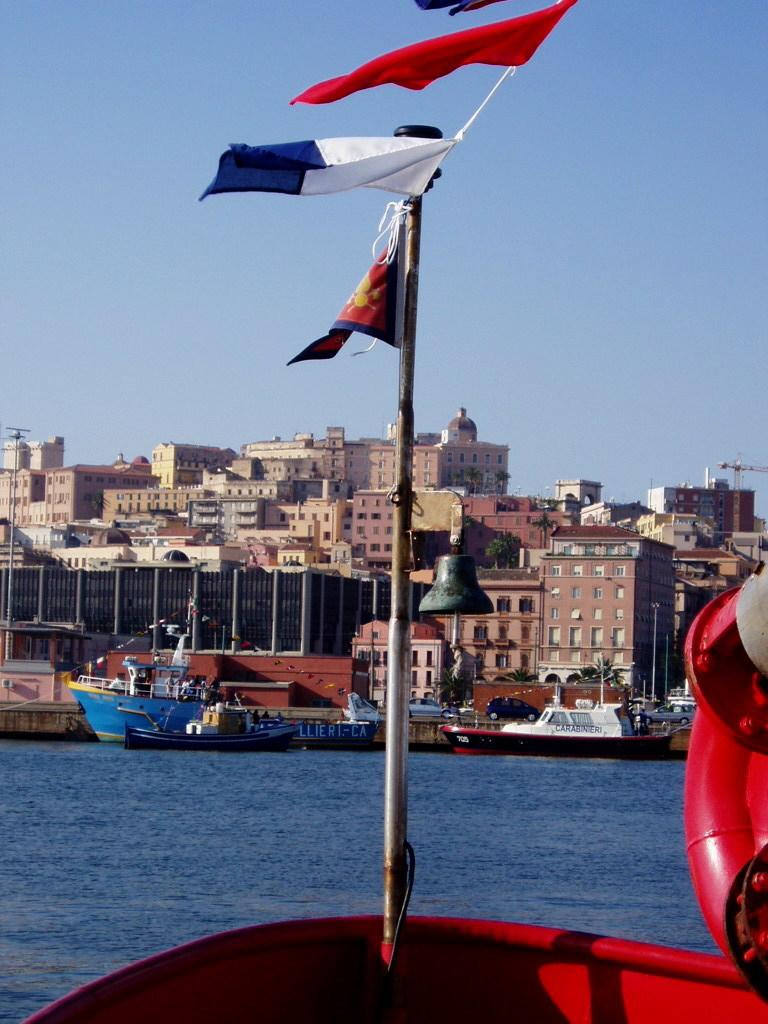What is floating on the water in the image? There are boats on the surface of the water in the image. What can be seen flying in the image? Flags are visible in the image. What type of structures can be seen in the image? There are buildings in the image. What type of vegetation is present in the image? There are trees in the image. What is visible above the boats and buildings in the image? The sky is visible in the image. What type of dinosaurs can be seen roaming around in the image? There are no dinosaurs present in the image; it features boats on the water, flags, buildings, trees, and the sky. 